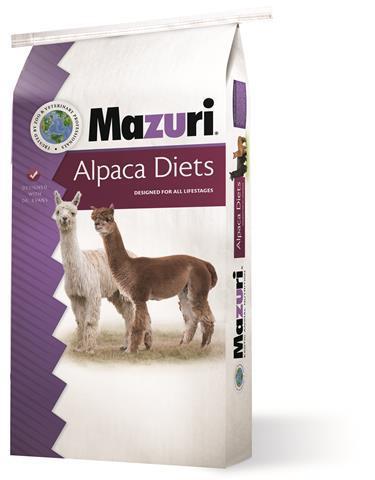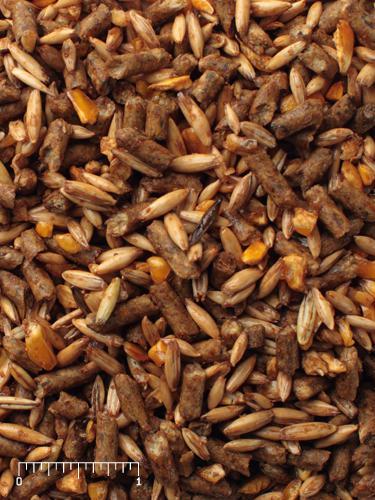The first image is the image on the left, the second image is the image on the right. For the images shown, is this caption "The left image contains one bag of food with two hooved animals on the front of the package, and the right image contains a mass of small bits of animal feed." true? Answer yes or no. Yes. The first image is the image on the left, the second image is the image on the right. Analyze the images presented: Is the assertion "One image shows loose pet food pellets and another image shows a bag of animal food." valid? Answer yes or no. Yes. 